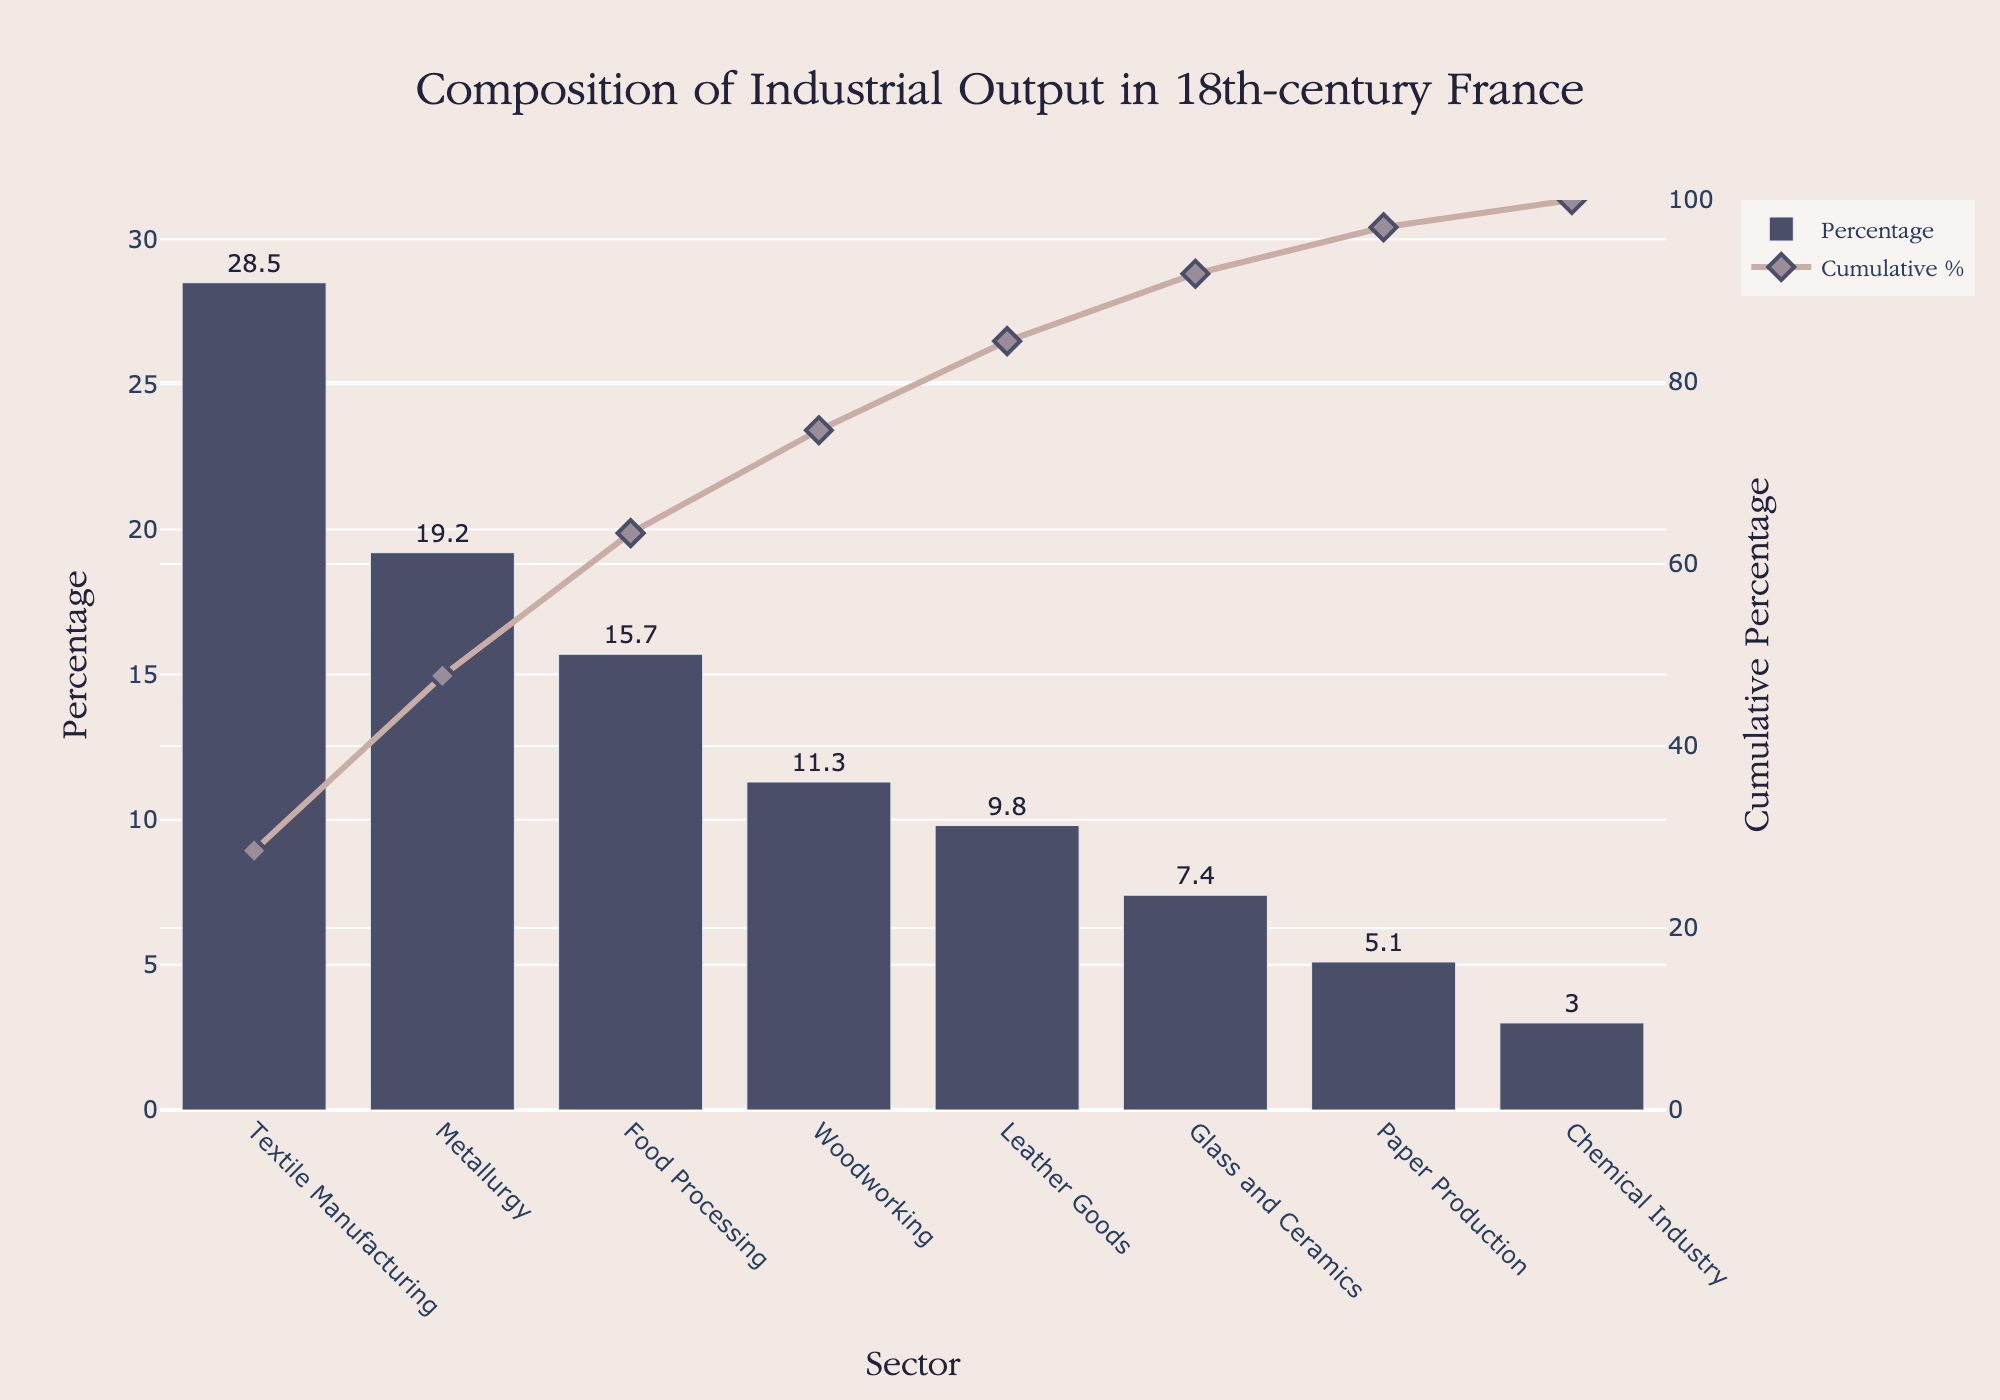What's the largest sector in terms of industrial output? The largest sector can be identified by looking at the bar with the highest percentage.
Answer: Textile Manufacturing What is the cumulative percentage after the top three sectors? To find the cumulative percentage, sum the percentages of the top three sectors: Textile Manufacturing (28.5%), Metallurgy (19.2%), and Food Processing (15.7%): 28.5 + 19.2 + 15.7 = 63.4%
Answer: 63.4% Which sector has the smallest output percentage? The smallest sector is indicated by the shortest bar in the plot.
Answer: Chemical Industry How do Textile Manufacturing and Metallurgy compare in terms of percentage? Compare the heights of the two bars: Textile Manufacturing has 28.5% while Metallurgy has 19.2%.
Answer: Textile Manufacturing has a higher percentage What percentage of the industrial output is contributed by the bottom three sectors combined? Sum the output percentages of the bottom three sectors: Glass and Ceramics (7.4%), Paper Production (5.1%), and Chemical Industry (3.0%): 7.4 + 5.1 + 3.0 = 15.5%.
Answer: 15.5% By how much does the cumulative percentage increase when Leather Goods are included after Woodworking? Add the percentages of Woodworking (11.3%) and Leather Goods (9.8%), and note their cumulative value starting from the preceding cumulative value before adding Woodworking. Initially, the cumulative before Woodworking is 63.4%. The cumulative percentage for Leather Goods is 63.4% + 11.3% = 74.7%. Adding Leather Goods: 74.7% + 9.8% = 84.5%. Thus, cumulative increase when Leather Goods is included after Woodworking: 84.5% - 74.7% = 9.8%.
Answer: 9.8% What is the cumulative percentage at Food Processing? Locate the bar for Food Processing and refer to its cumulative percentage. This is after Textile Manufacturing and Metallurgy: 28.5% + 19.2% + 15.7% = 63.4%.
Answer: 63.4% Which sector contributes more to industrial output: Woodworking or Leather Goods? Compare the percentages. Woodworking has 11.3%, and Leather Goods has 9.8%, so Woodworking contributes more.
Answer: Woodworking What percentage difference exists between Metallurgy and Textile Manufacturing? Subtract the percentage of Textile Manufacturing (28.5%) from Metallurgy (19.2%): 28.5% - 19.2% = 9.3%.
Answer: 9.3% What sectors together make up over half of the industrial output? Find the cumulative percentages until they exceed 50%. Textile Manufacturing (28.5%) and Metallurgy (19.2%) together make 47.7%, and adding Food Processing (15.7%) brings the total to 63.4%.
Answer: Textile Manufacturing, Metallurgy, and Food Processing 